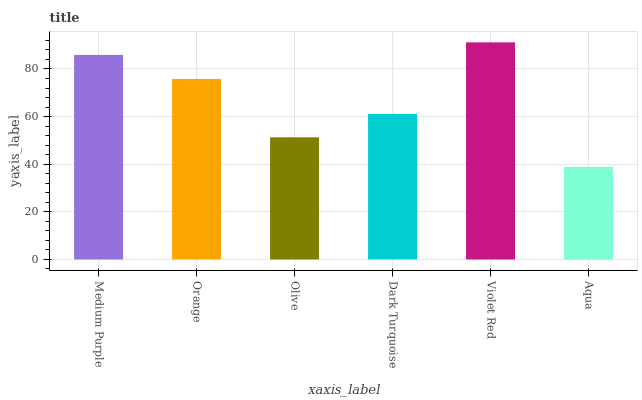Is Aqua the minimum?
Answer yes or no. Yes. Is Violet Red the maximum?
Answer yes or no. Yes. Is Orange the minimum?
Answer yes or no. No. Is Orange the maximum?
Answer yes or no. No. Is Medium Purple greater than Orange?
Answer yes or no. Yes. Is Orange less than Medium Purple?
Answer yes or no. Yes. Is Orange greater than Medium Purple?
Answer yes or no. No. Is Medium Purple less than Orange?
Answer yes or no. No. Is Orange the high median?
Answer yes or no. Yes. Is Dark Turquoise the low median?
Answer yes or no. Yes. Is Violet Red the high median?
Answer yes or no. No. Is Violet Red the low median?
Answer yes or no. No. 